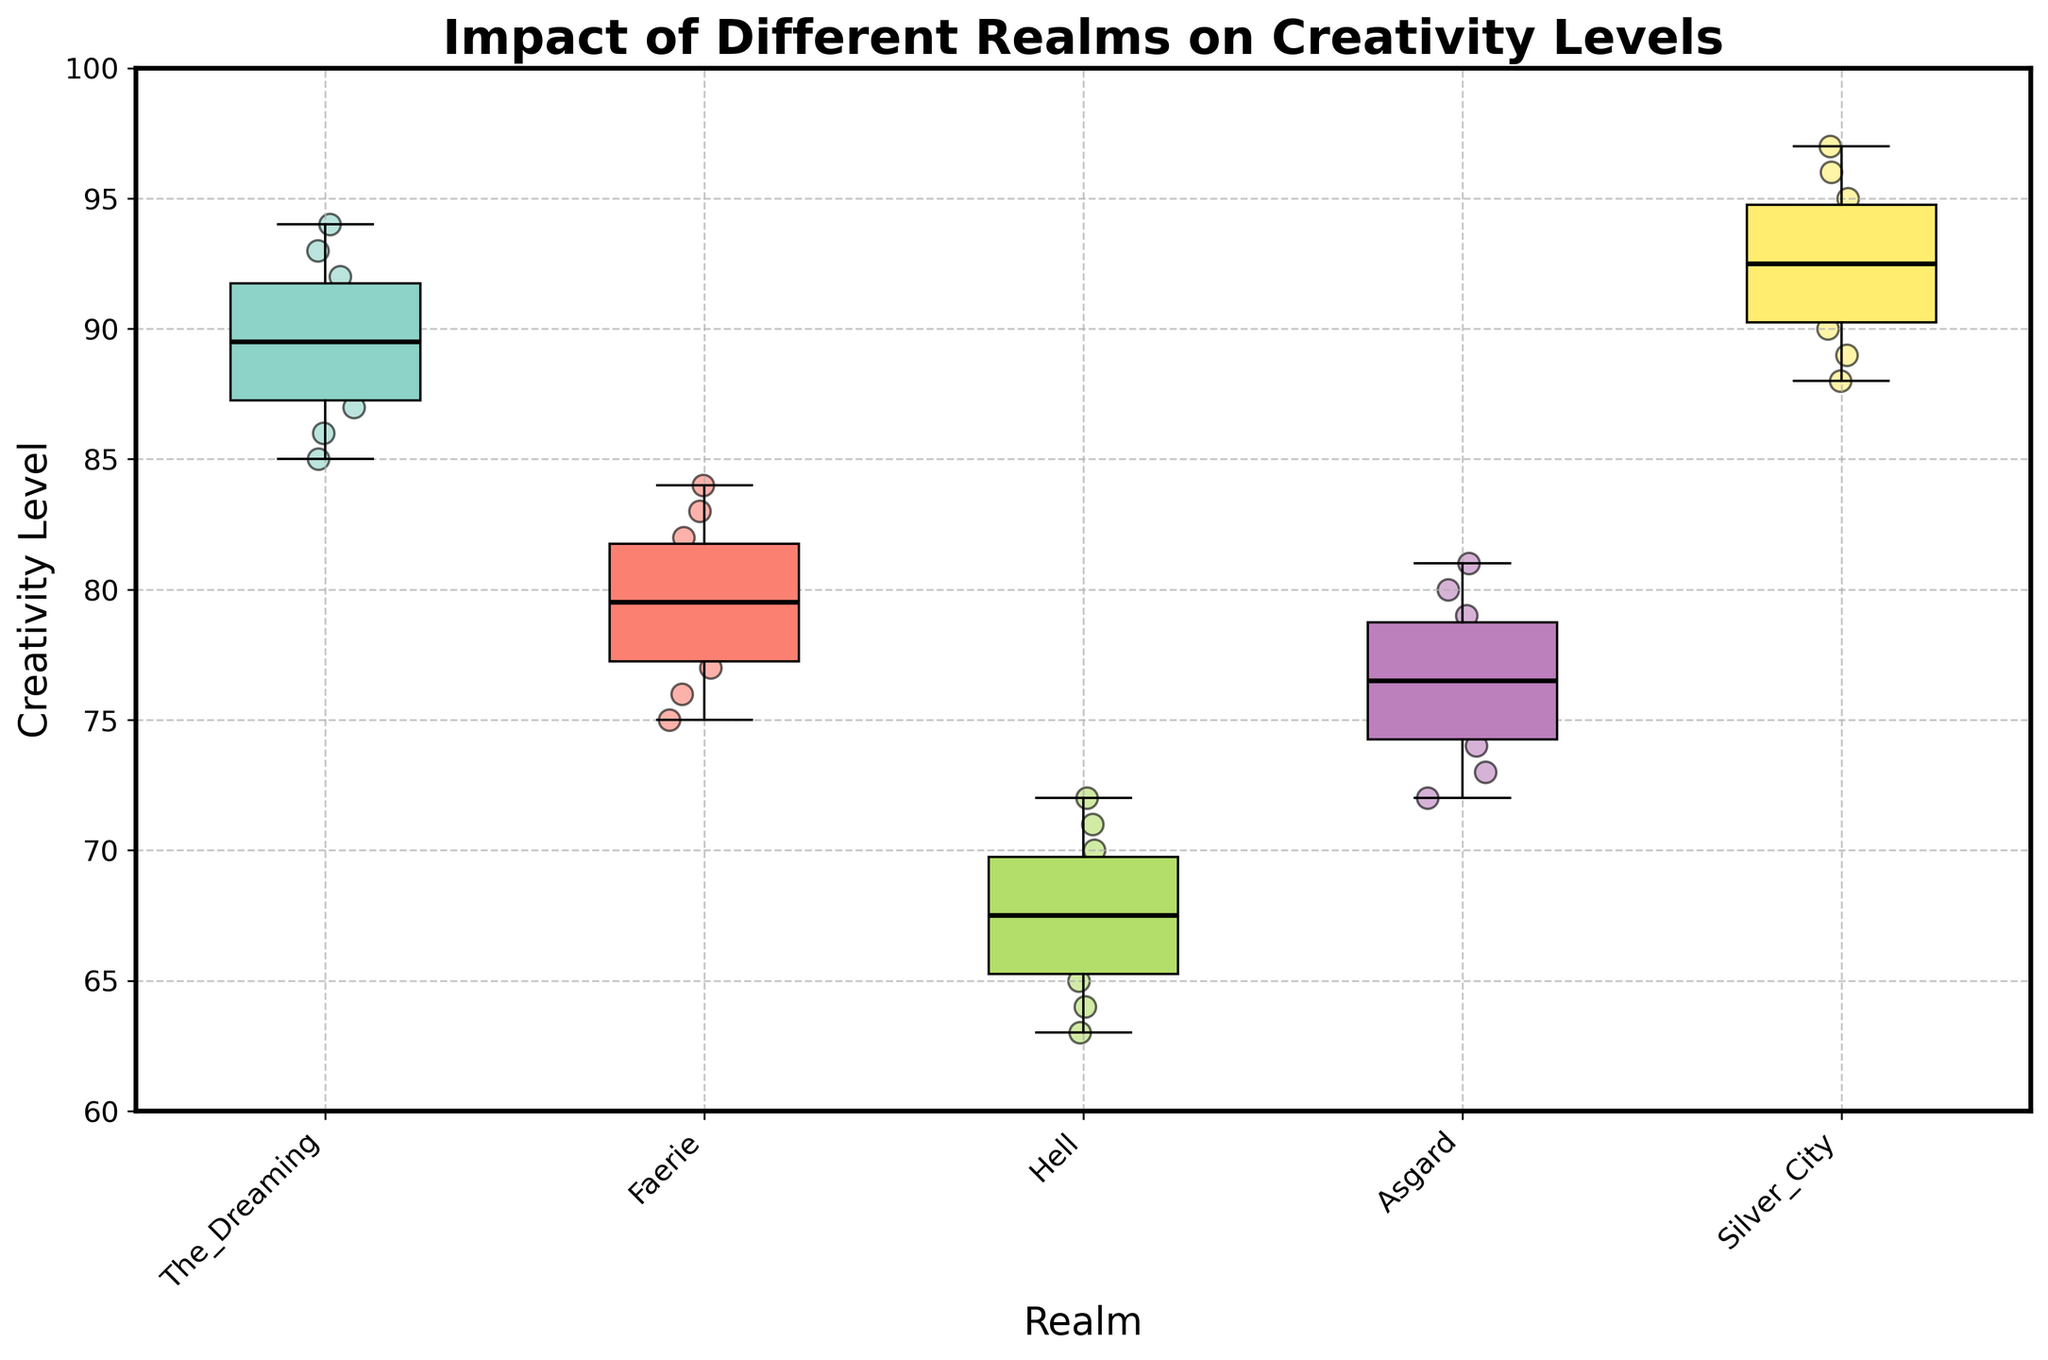What is the title of the figure? The title is prominently displayed at the top of the plot. Reading it directly gives us the answer: "Impact of Different Realms on Creativity Levels".
Answer: Impact of Different Realms on Creativity Levels Which realm has the highest median creativity level? To find the median, we look at the horizontal line inside each box. The Silver City has the highest median line among all realms.
Answer: Silver City What is the range of creativity levels in Asgard? The range can be determined by the length of the box plot and whiskers for Asgard. The minimum is around 72, and the maximum is around 81.
Answer: 72 to 81 How do the creativity levels of The Dreaming compare to those of Hell? We compare the central tendencies and distributions. The median for The Dreaming is higher and the spread is narrower than for Hell. Additionally, The Dreaming's data points are higher on average.
Answer: The Dreaming has higher and less variable creativity levels What is the interquartile range (IQR) for Faerie's creativity levels? The IQR is the difference between the third quartile (top of the box) and the first quartile (bottom of the box). For Faerie, the first quartile is around 76, and the third quartile is around 82.
Answer: 6 (82 - 76) How many data points are there in The Dreaming realm? Each scatter point represents a data point in the plot. By counting the dots above The Dreaming box plot, we see there are 10.
Answer: 10 Which realm shows the greatest variation in creativity levels? Variation can be inferred from the length of the boxes and whiskers. Hell's creativity levels have the largest spread from the minimum to the maximum, indicating the greatest variation.
Answer: Hell What's the difference between the maximum creativity levels of Silver City and Faerie? The maximum level for Silver City is around 97 and for Faerie is around 84. Subtracting these gives the difference.
Answer: 13 (97 - 84) Which realm has the lowest minimum creativity level? The minimum creativity level is represented by the lowest point of the whisker. Hell has the lowest minimum level among all realms.
Answer: Hell How do the creativity levels in Faerie compare with those in Asgard in terms of central tendency and spread? Comparing the medians (central lines in the boxes), both realms have similar medians. However, spread (IQR) for Asgard seems smaller than Faerie, indicating less variation.
Answer: Similar central tendency, Asgard has less spread 